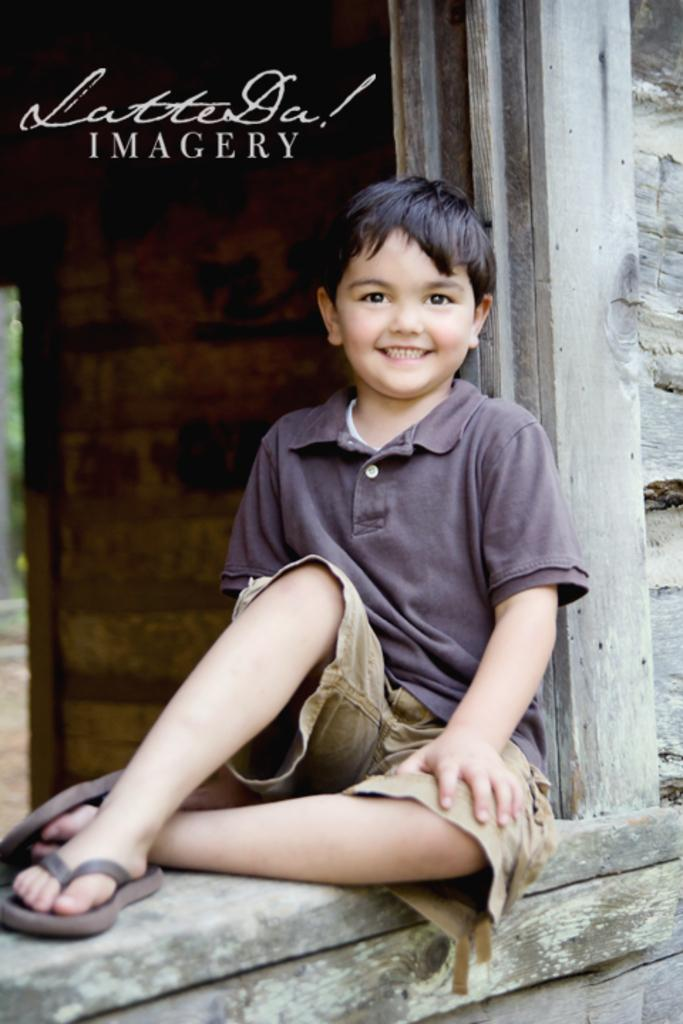Who is the main subject in the image? There is a boy in the image. What is the boy sitting on? The boy is sitting on a wooden surface. What can be seen in the background of the image? There is a wall in the background of the image. Is there any text or writing in the image? Yes, there is text or writing in the left top corner of the image. What type of umbrella is the boy holding in the image? There is no umbrella present in the image. Can you tell me how many wrens are sitting on the boy's shoulder in the image? There are no wrens present in the image. 